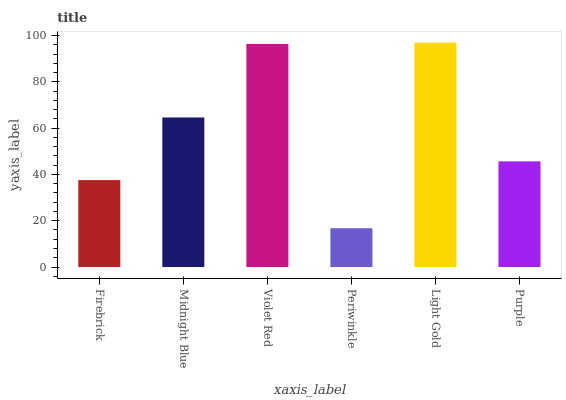Is Periwinkle the minimum?
Answer yes or no. Yes. Is Light Gold the maximum?
Answer yes or no. Yes. Is Midnight Blue the minimum?
Answer yes or no. No. Is Midnight Blue the maximum?
Answer yes or no. No. Is Midnight Blue greater than Firebrick?
Answer yes or no. Yes. Is Firebrick less than Midnight Blue?
Answer yes or no. Yes. Is Firebrick greater than Midnight Blue?
Answer yes or no. No. Is Midnight Blue less than Firebrick?
Answer yes or no. No. Is Midnight Blue the high median?
Answer yes or no. Yes. Is Purple the low median?
Answer yes or no. Yes. Is Periwinkle the high median?
Answer yes or no. No. Is Firebrick the low median?
Answer yes or no. No. 